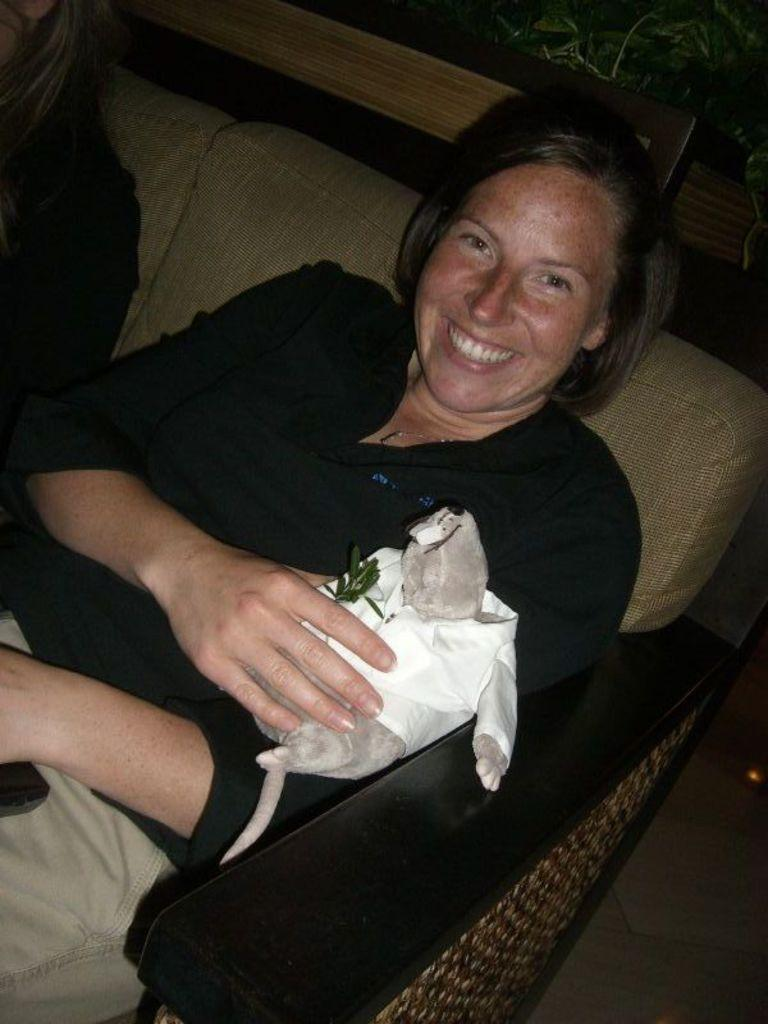Who is present in the image? There is a woman and another girl in the image. What is the woman doing in the image? The woman is sitting on a sofa and holding a doll. Where is the girl sitting in relation to the woman? The girl is sitting on the same sofa as the woman. Reasoning: Let' Let's think step by step in order to produce the conversation. We start by identifying the people present in the image, which are a woman and a girl. Then, we describe the actions and positions of these individuals, noting that the woman is sitting on a sofa and holding a doll, while the girl is also sitting on the same sofa. Each question is designed to elicit a specific detail about the image that is known from the provided facts. Absurd Question/Answer: What type of oatmeal is the woman cooking for the girl in the image? There is no mention of oatmeal or cooking in the image; the woman is holding a doll and sitting on a sofa with the girl. 